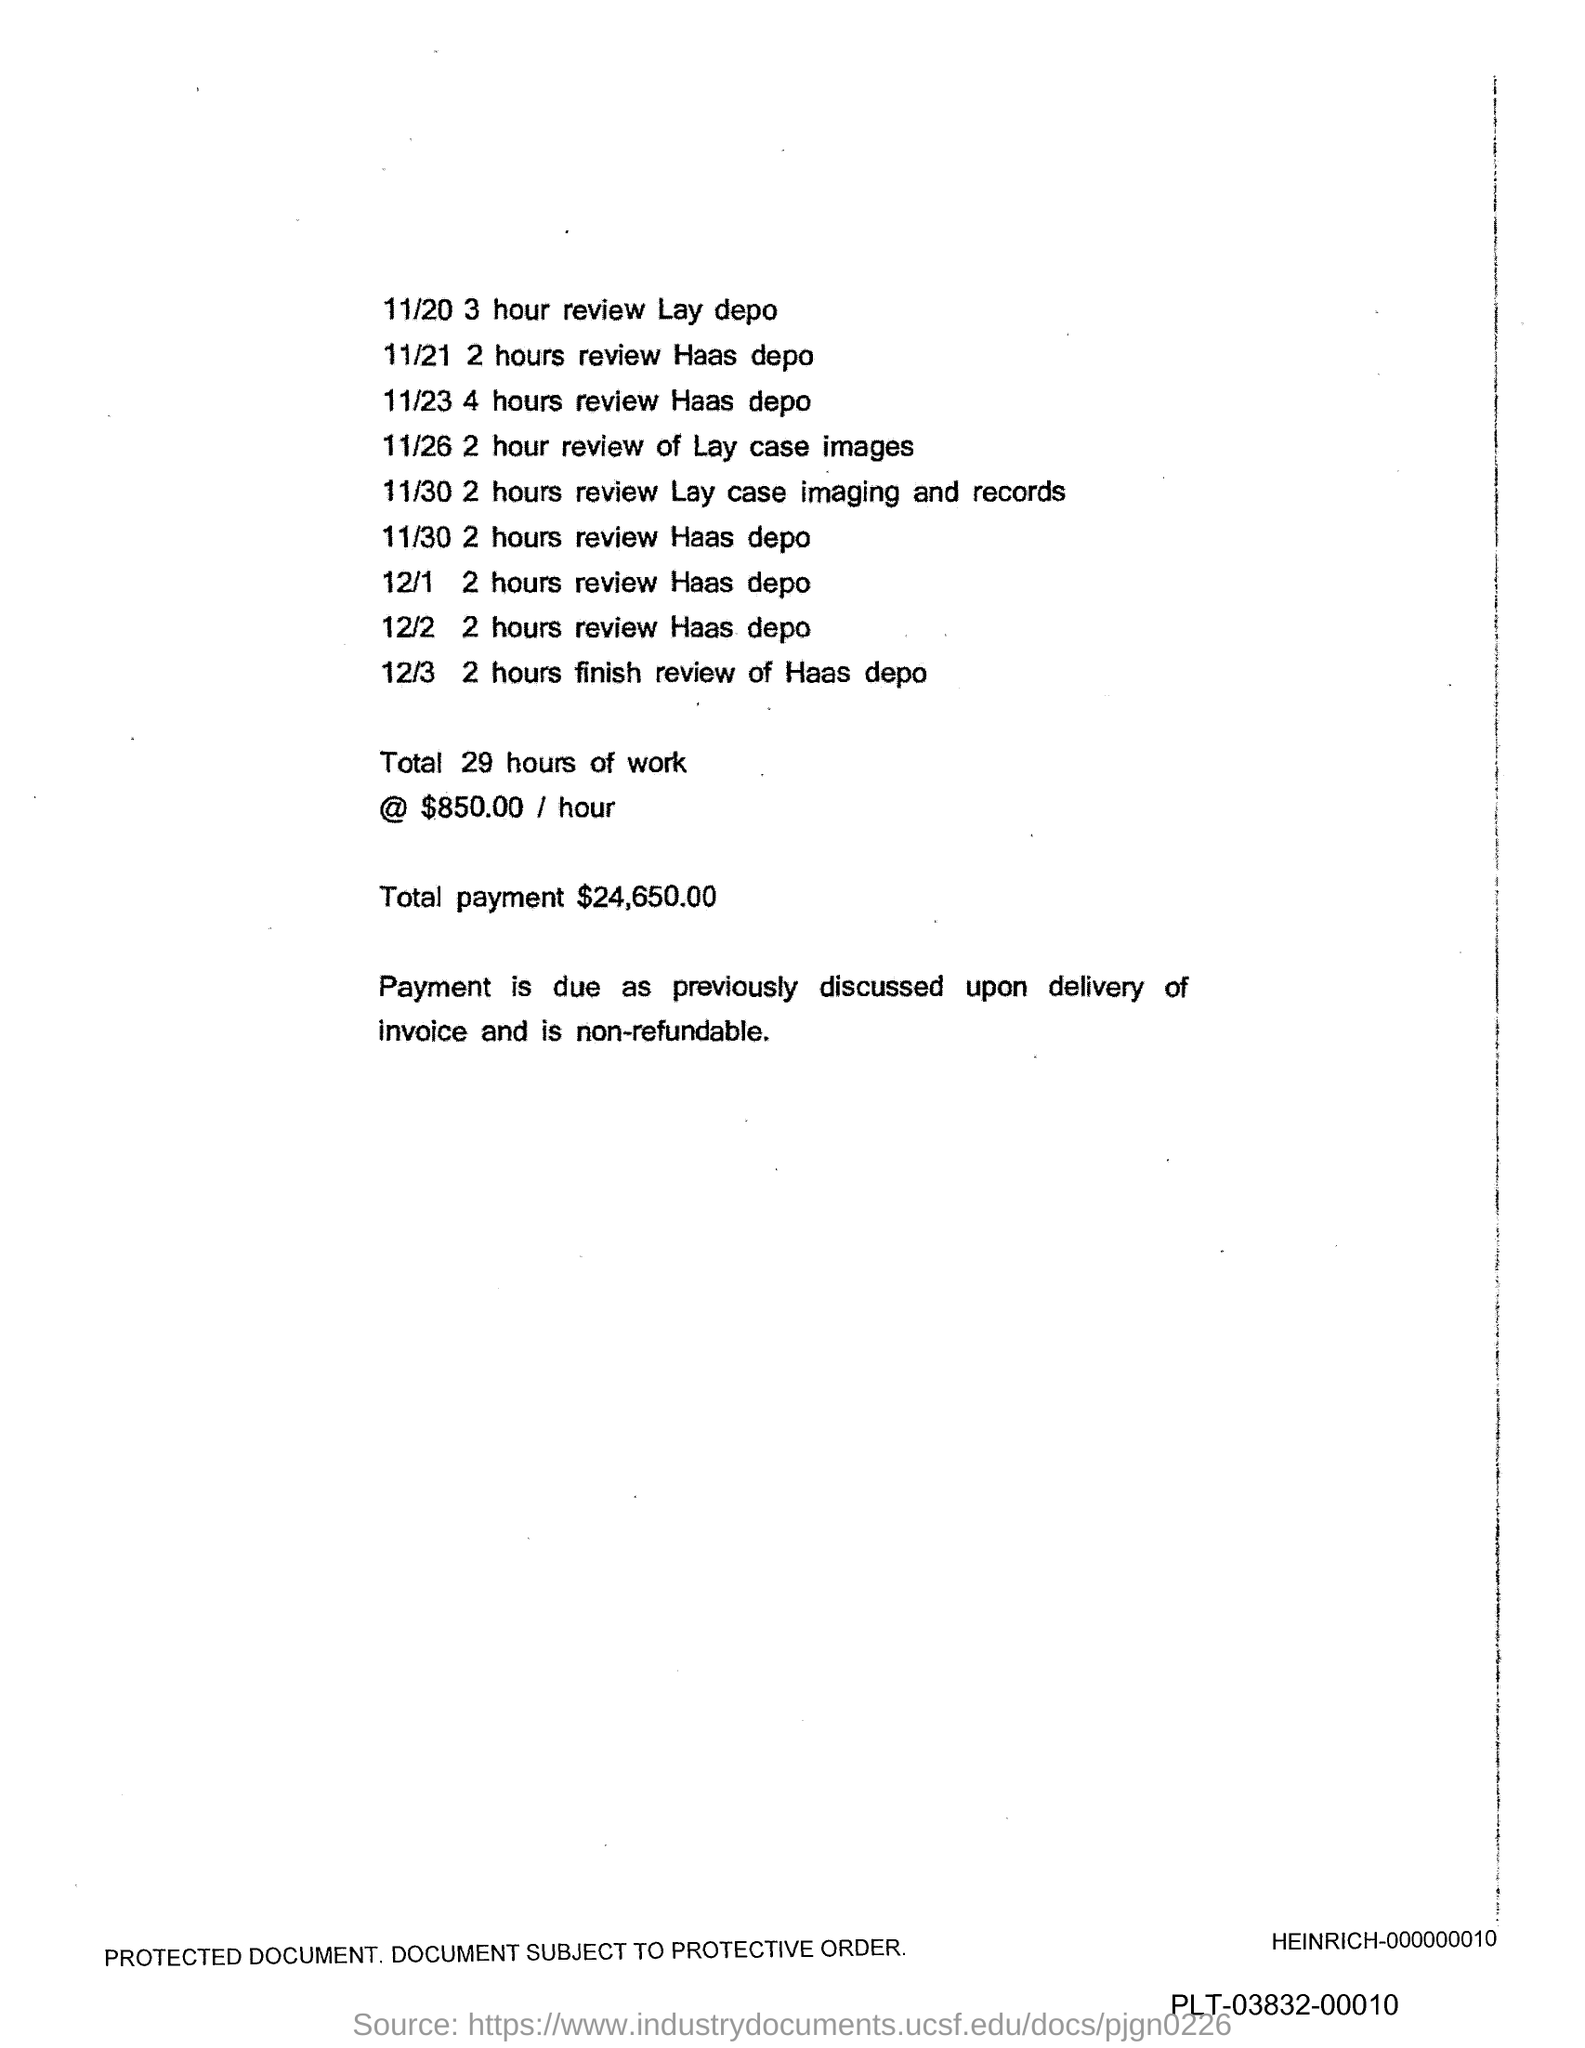What is the total payment ?
Offer a very short reply. $24,650.00. 